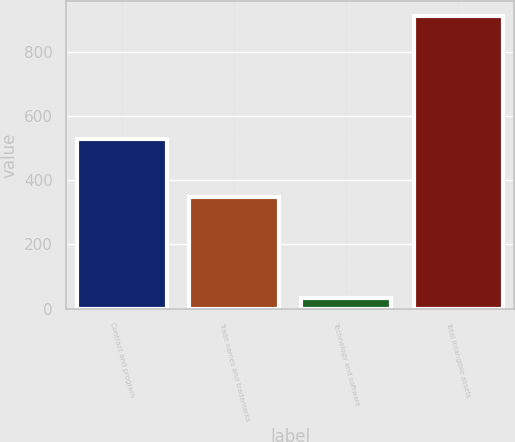Convert chart. <chart><loc_0><loc_0><loc_500><loc_500><bar_chart><fcel>Contract and program<fcel>Trade names and trademarks<fcel>Technology and software<fcel>Total intangible assets<nl><fcel>529<fcel>349<fcel>33<fcel>912<nl></chart> 